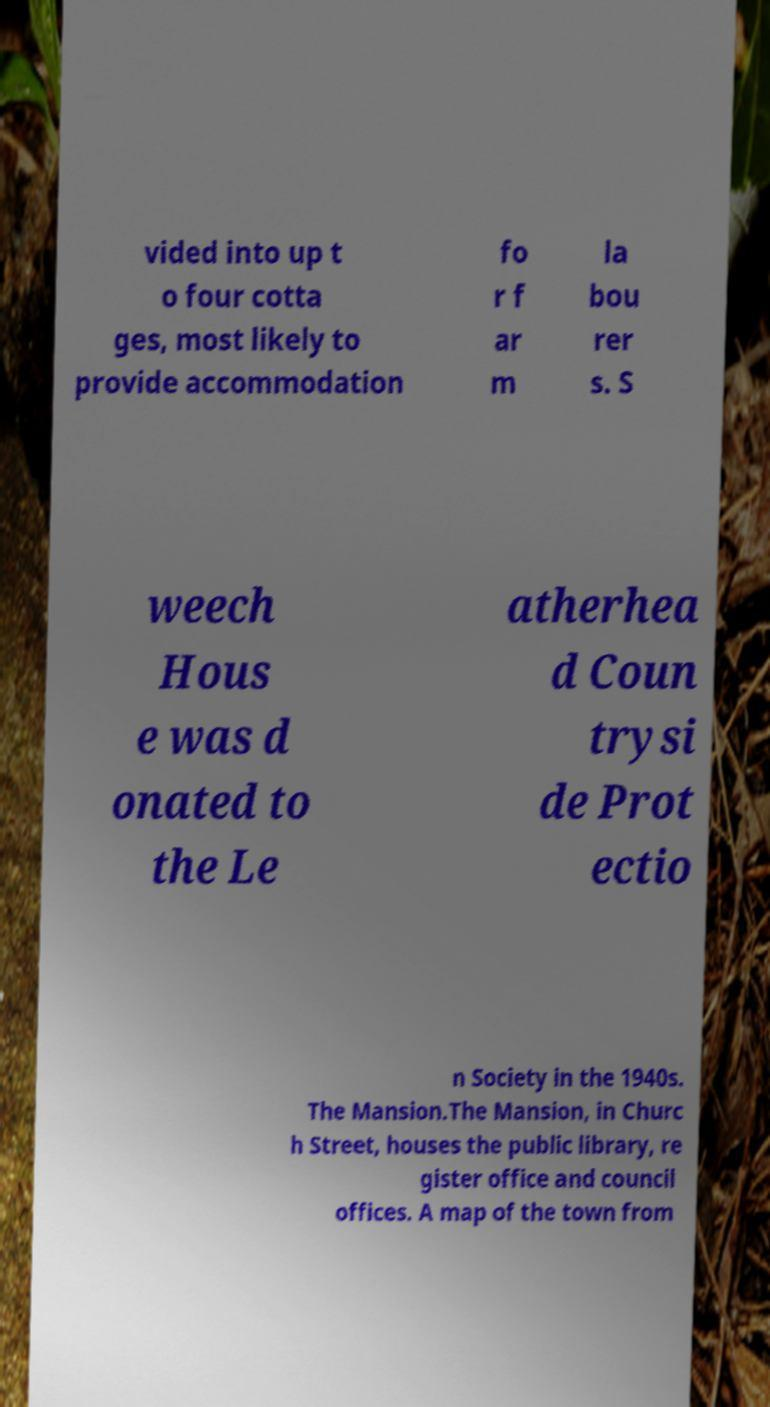Could you extract and type out the text from this image? vided into up t o four cotta ges, most likely to provide accommodation fo r f ar m la bou rer s. S weech Hous e was d onated to the Le atherhea d Coun trysi de Prot ectio n Society in the 1940s. The Mansion.The Mansion, in Churc h Street, houses the public library, re gister office and council offices. A map of the town from 